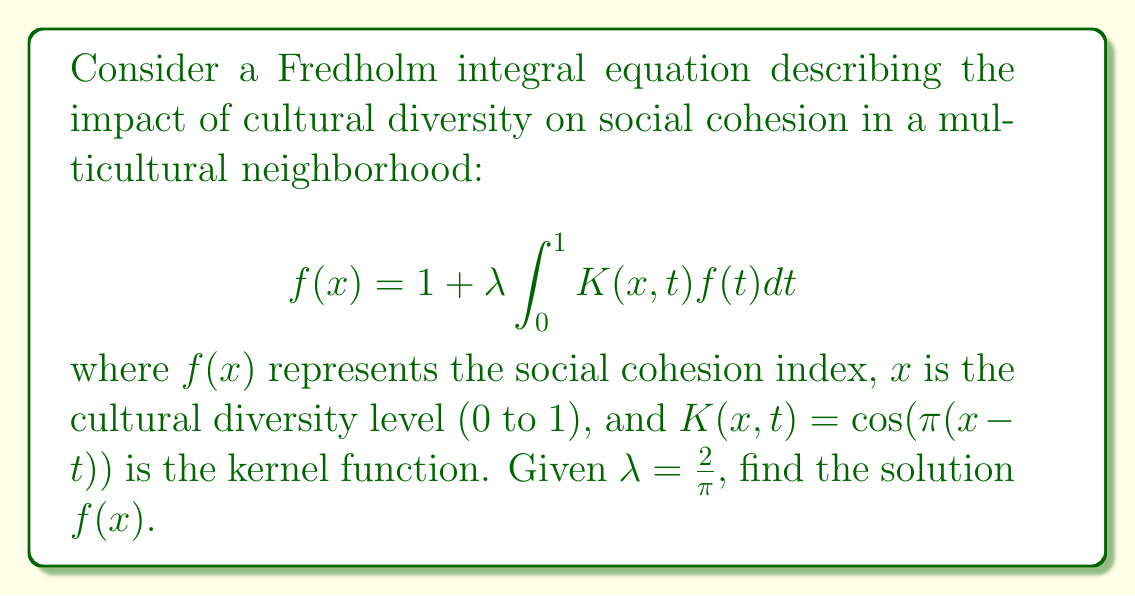Show me your answer to this math problem. 1) We assume the solution has the form $f(x) = a + b\cos(\pi x)$, where $a$ and $b$ are constants to be determined.

2) Substitute this into the integral equation:

   $$a + b\cos(\pi x) = 1 + \frac{2}{\pi} \int_0^1 \cos(\pi(x-t))(a + b\cos(\pi t))dt$$

3) Expand the cosine term in the integrand:

   $$a + b\cos(\pi x) = 1 + \frac{2}{\pi} \int_0^1 [\cos(\pi x)\cos(\pi t) + \sin(\pi x)\sin(\pi t)](a + b\cos(\pi t))dt$$

4) Evaluate the integrals:

   $$\int_0^1 \cos(\pi t)dt = 0$$
   $$\int_0^1 \cos^2(\pi t)dt = \frac{1}{2}$$
   $$\int_0^1 \sin(\pi t)dt = 0$$

5) After integration:

   $$a + b\cos(\pi x) = 1 + \frac{2}{\pi} [a\cos(\pi x) \cdot 0 + b\cos(\pi x) \cdot \frac{1}{2}]$$

6) Simplify:

   $$a + b\cos(\pi x) = 1 + b\cos(\pi x)$$

7) Equate coefficients:

   $a = 1$
   $b = b$

8) Therefore, the solution is:

   $$f(x) = 1 + b\cos(\pi x)$$

   where $b$ is an arbitrary constant.
Answer: $f(x) = 1 + b\cos(\pi x)$, where $b$ is an arbitrary constant 